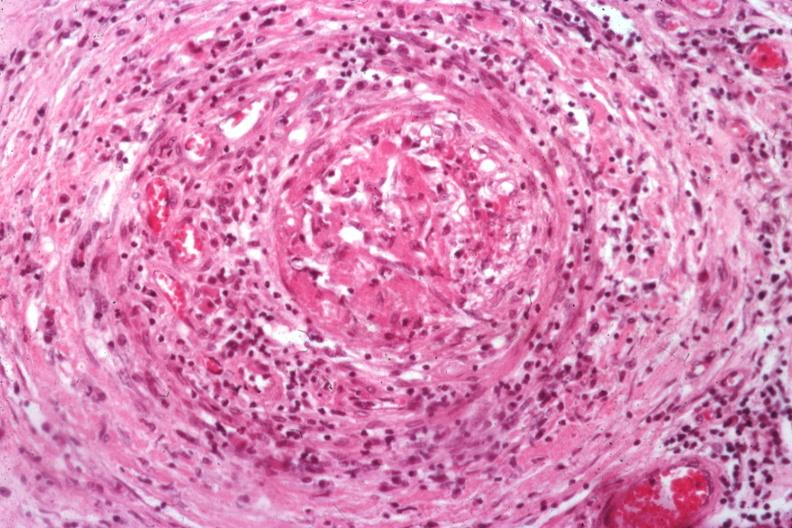what is present?
Answer the question using a single word or phrase. Testicle 